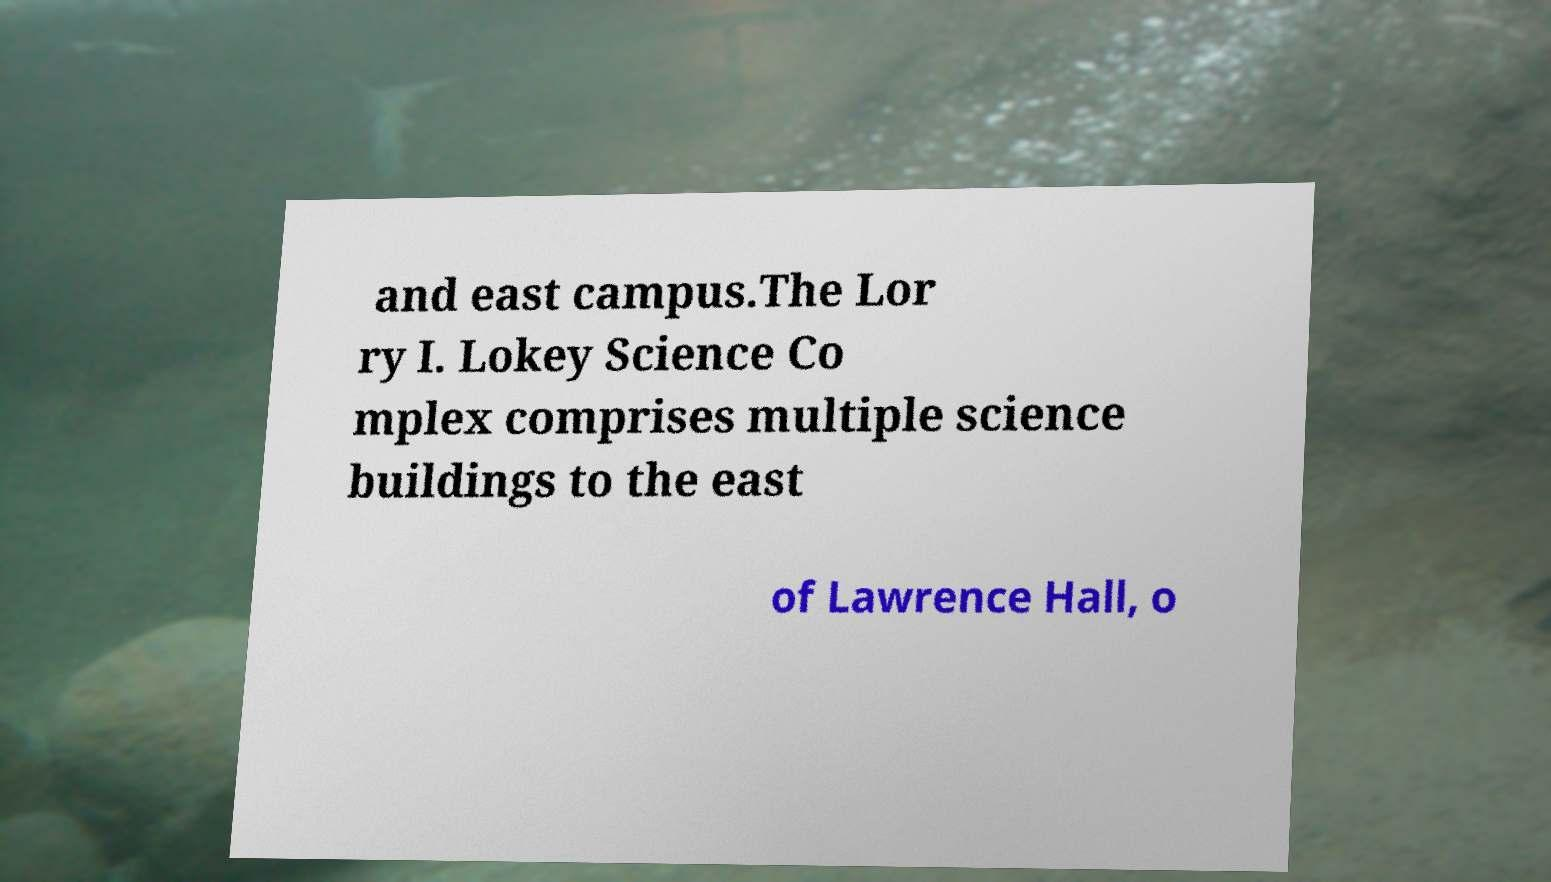Could you extract and type out the text from this image? and east campus.The Lor ry I. Lokey Science Co mplex comprises multiple science buildings to the east of Lawrence Hall, o 